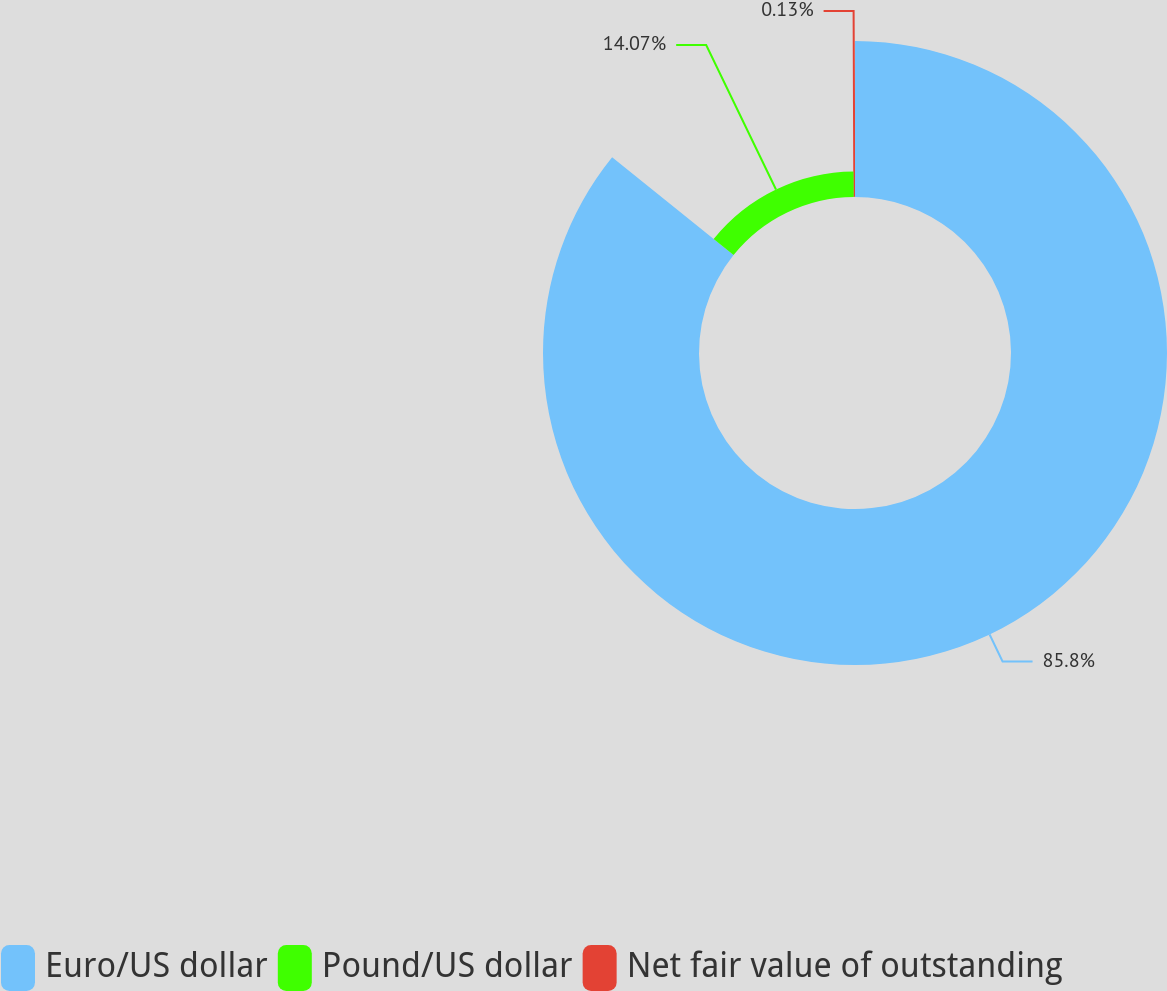Convert chart. <chart><loc_0><loc_0><loc_500><loc_500><pie_chart><fcel>Euro/US dollar<fcel>Pound/US dollar<fcel>Net fair value of outstanding<nl><fcel>85.8%<fcel>14.07%<fcel>0.13%<nl></chart> 